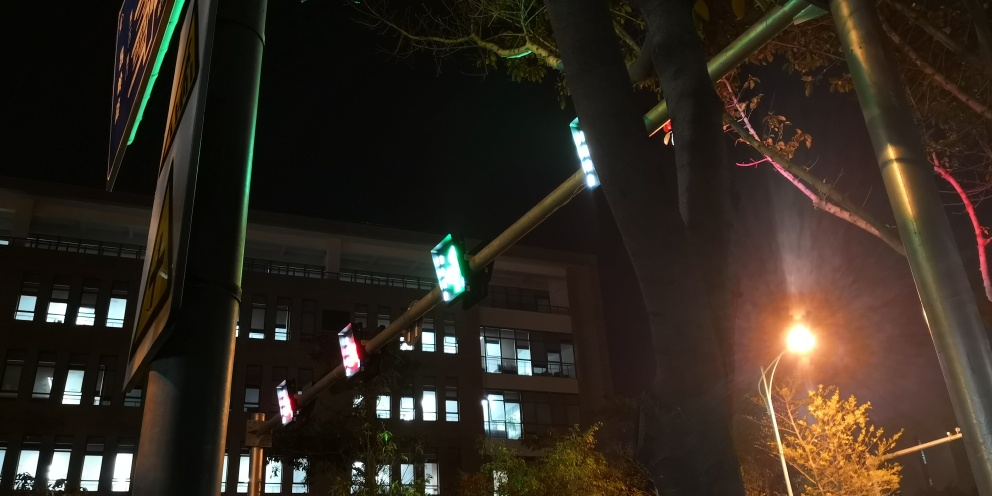Does the underexposure affect the texture details? Underexposure generally results in loss of detail in darker areas of an image, as shadows can become too deep, obscuring the details. In the provided photograph, it appears that some texture details could potentially be obscured due to the relative darkness of the scene, especially in areas that do not receive direct illumination from artificial light sources. 